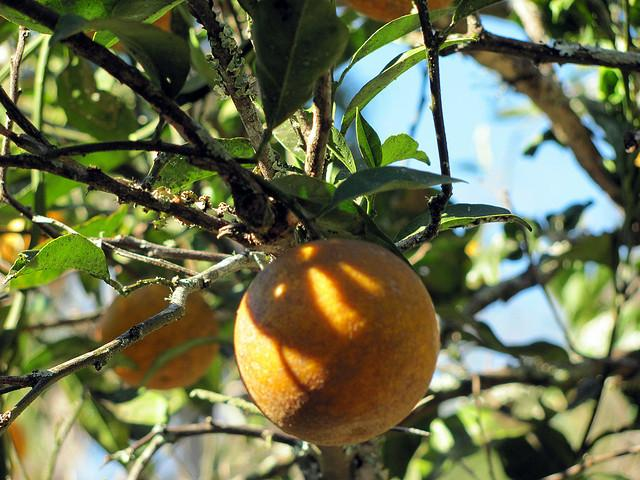Which acid is present in orange? citric 